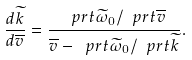Convert formula to latex. <formula><loc_0><loc_0><loc_500><loc_500>\frac { d \widetilde { k } } { d \overline { v } } = \frac { \ p r t \widetilde { \omega } _ { 0 } / \ p r t \overline { v } } { \overline { v } - \ p r t \widetilde { \omega } _ { 0 } / \ p r t \widetilde { k } } .</formula> 